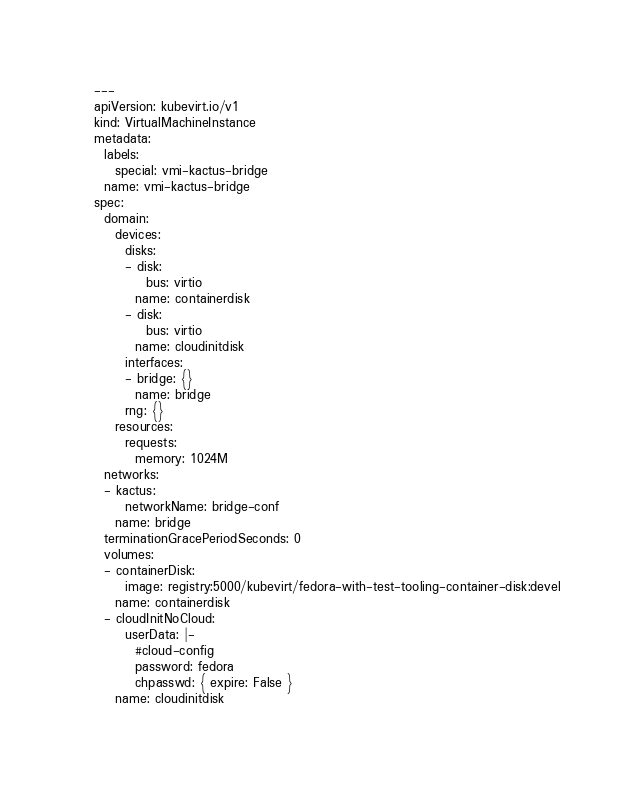<code> <loc_0><loc_0><loc_500><loc_500><_YAML_>---
apiVersion: kubevirt.io/v1
kind: VirtualMachineInstance
metadata:
  labels:
    special: vmi-kactus-bridge
  name: vmi-kactus-bridge
spec:
  domain:
    devices:
      disks:
      - disk:
          bus: virtio
        name: containerdisk
      - disk:
          bus: virtio
        name: cloudinitdisk
      interfaces:
      - bridge: {}
        name: bridge
      rng: {}
    resources:
      requests:
        memory: 1024M
  networks:
  - kactus:
      networkName: bridge-conf
    name: bridge
  terminationGracePeriodSeconds: 0
  volumes:
  - containerDisk:
      image: registry:5000/kubevirt/fedora-with-test-tooling-container-disk:devel
    name: containerdisk
  - cloudInitNoCloud:
      userData: |-
        #cloud-config
        password: fedora
        chpasswd: { expire: False }
    name: cloudinitdisk
</code> 